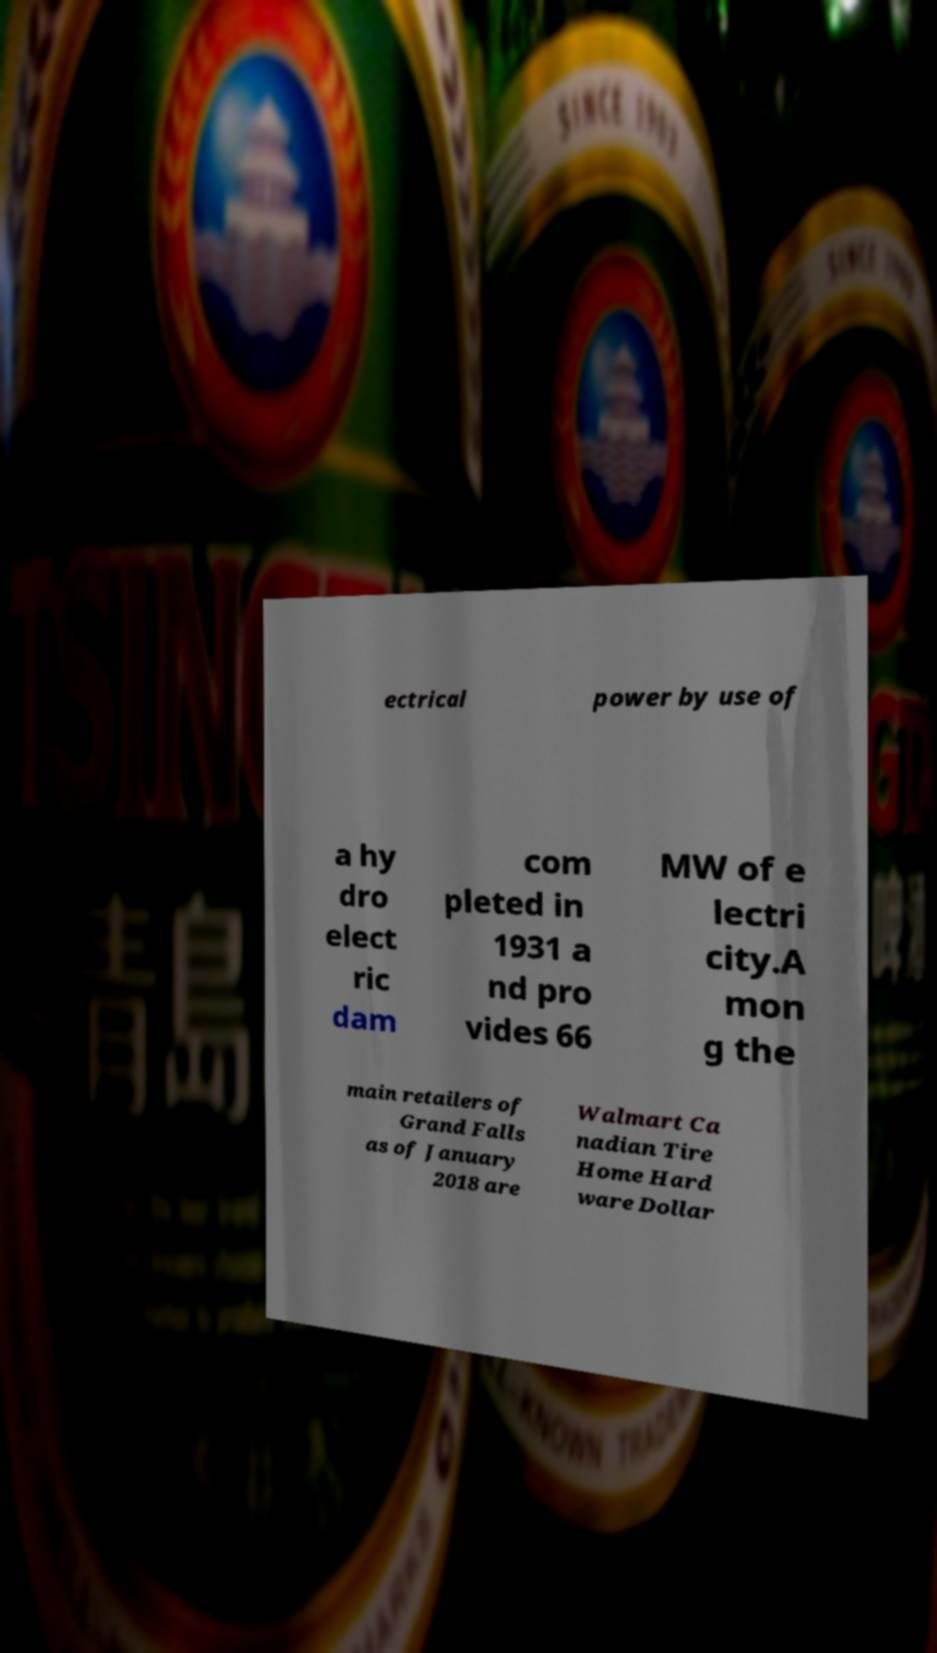Can you accurately transcribe the text from the provided image for me? ectrical power by use of a hy dro elect ric dam com pleted in 1931 a nd pro vides 66 MW of e lectri city.A mon g the main retailers of Grand Falls as of January 2018 are Walmart Ca nadian Tire Home Hard ware Dollar 